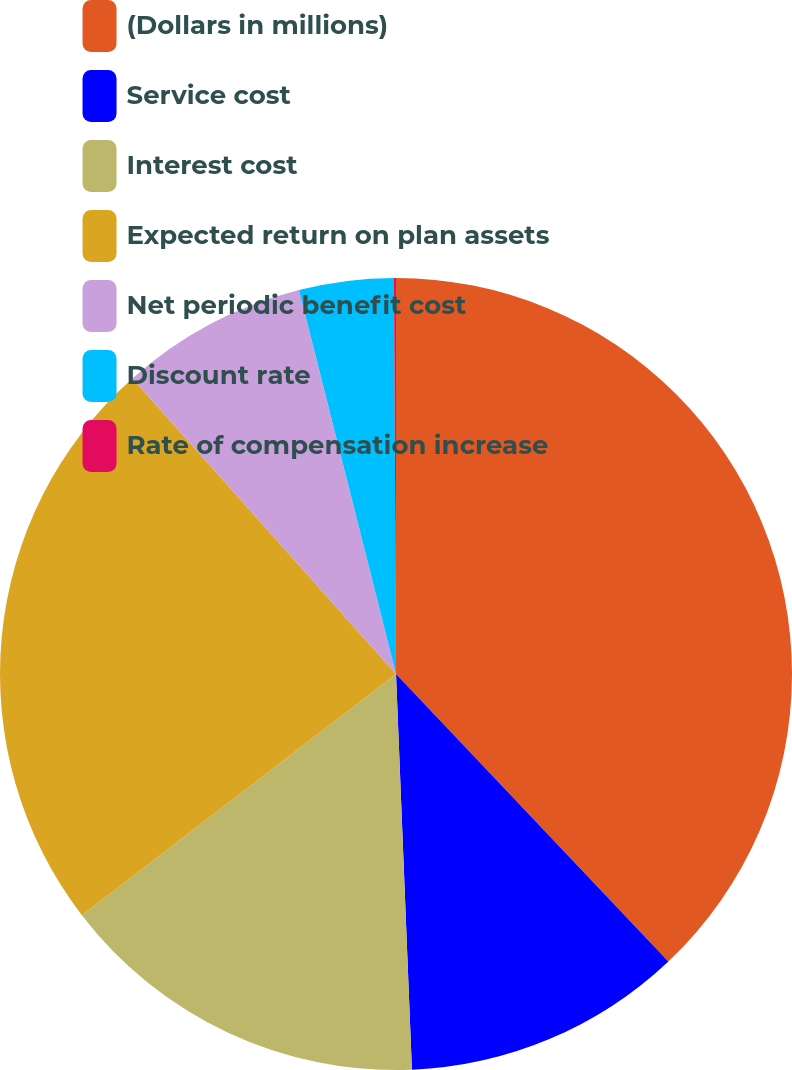<chart> <loc_0><loc_0><loc_500><loc_500><pie_chart><fcel>(Dollars in millions)<fcel>Service cost<fcel>Interest cost<fcel>Expected return on plan assets<fcel>Net periodic benefit cost<fcel>Discount rate<fcel>Rate of compensation increase<nl><fcel>37.93%<fcel>11.43%<fcel>15.22%<fcel>23.83%<fcel>7.65%<fcel>3.86%<fcel>0.08%<nl></chart> 